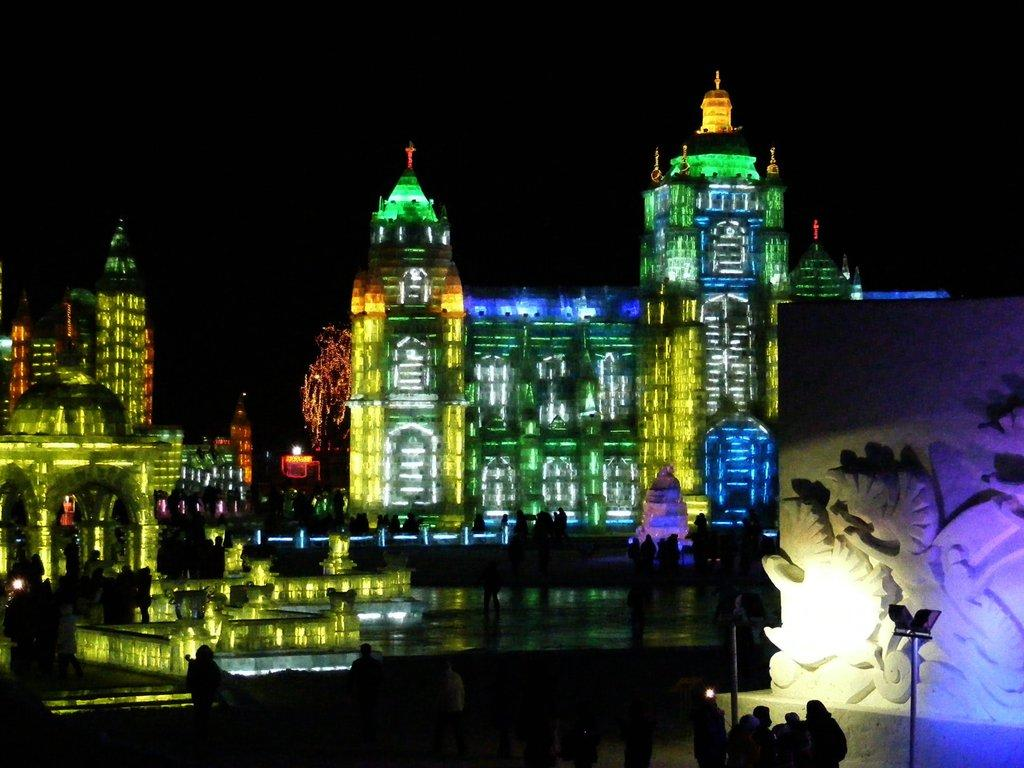What is located in the middle of the picture? There are buildings in the middle of the picture. What colors are the lights on the buildings? The buildings have yellow, green, blue, and orange lights. What is the color of the background in the image? The background of the image is dark. Can you tell me how many pairs of shoes are visible in the image? There are no shoes present in the image; it features buildings with lights. What type of kiss is being exchanged between the buildings in the image? There is no kiss depicted in the image; it is a scene of buildings with lights. 